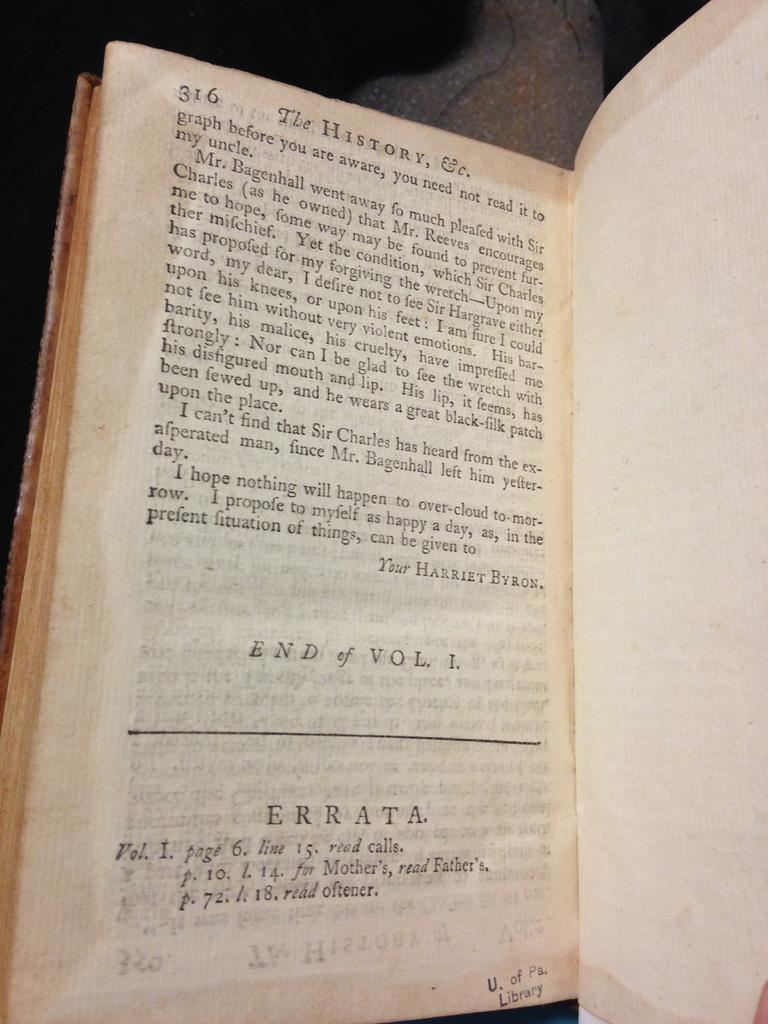Provide a one-sentence caption for the provided image. A book from U. of Pa. Library opened up to page 316. 